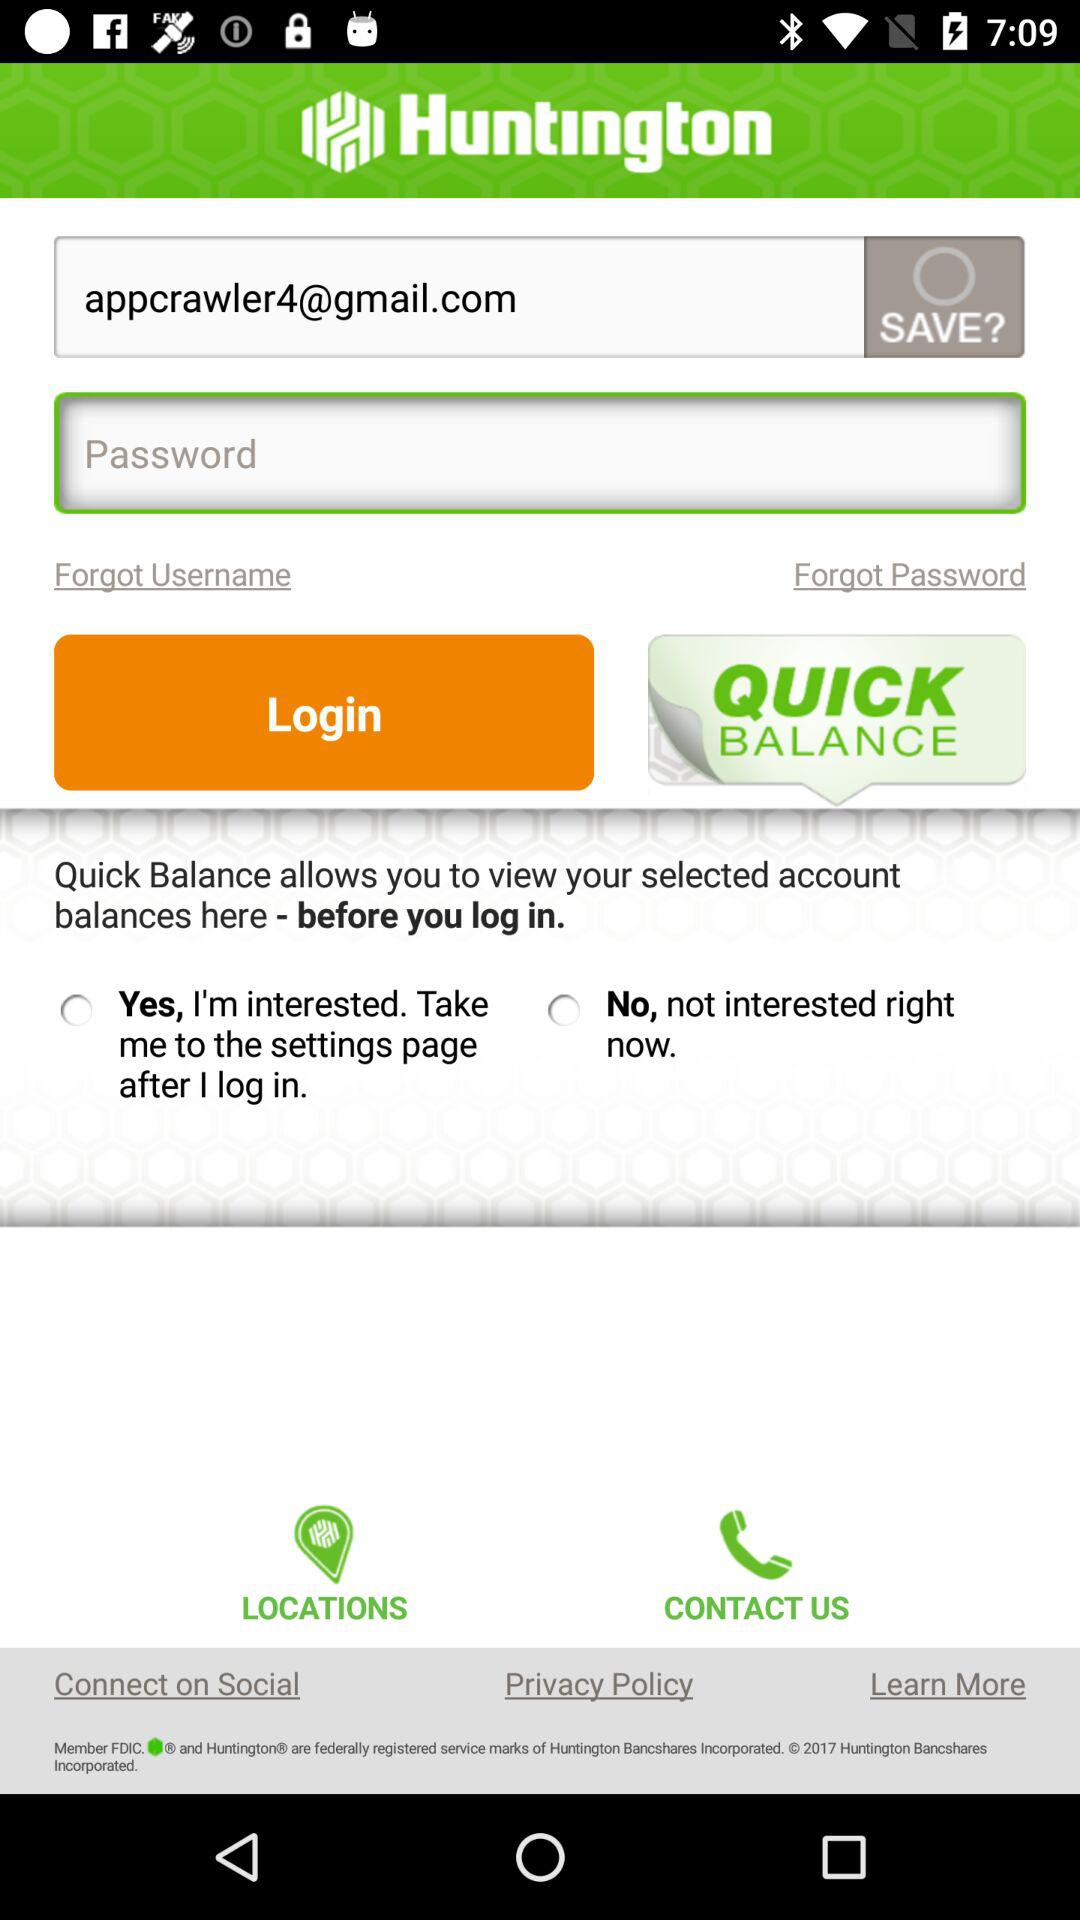What email address is entered? The entered email address is appcrawler4@gmail.com. 